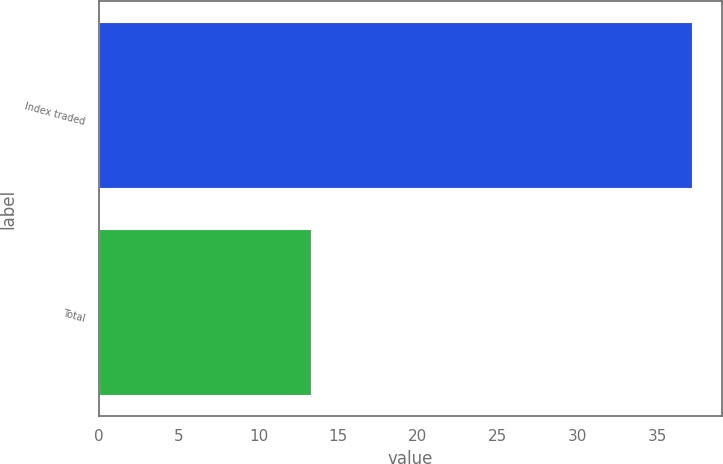Convert chart. <chart><loc_0><loc_0><loc_500><loc_500><bar_chart><fcel>Index traded<fcel>Total<nl><fcel>37.2<fcel>13.3<nl></chart> 